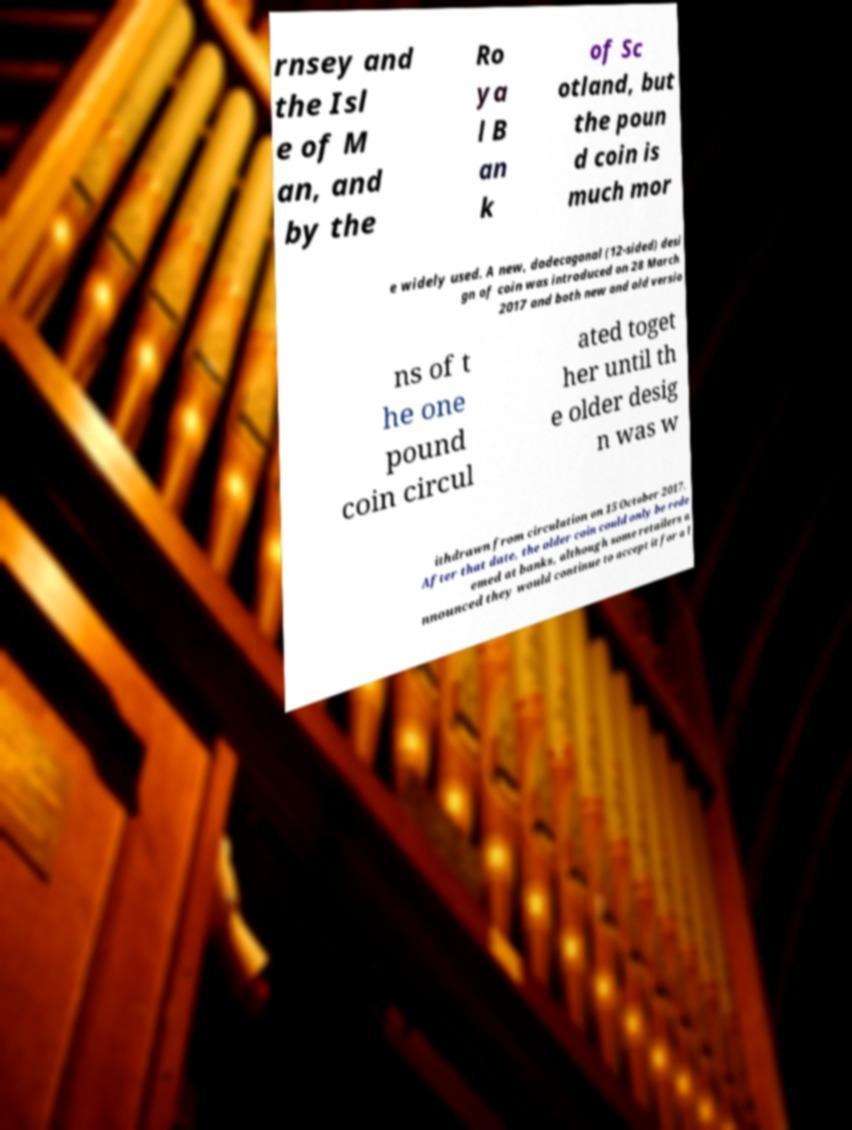Please identify and transcribe the text found in this image. rnsey and the Isl e of M an, and by the Ro ya l B an k of Sc otland, but the poun d coin is much mor e widely used. A new, dodecagonal (12-sided) desi gn of coin was introduced on 28 March 2017 and both new and old versio ns of t he one pound coin circul ated toget her until th e older desig n was w ithdrawn from circulation on 15 October 2017. After that date, the older coin could only be rede emed at banks, although some retailers a nnounced they would continue to accept it for a l 